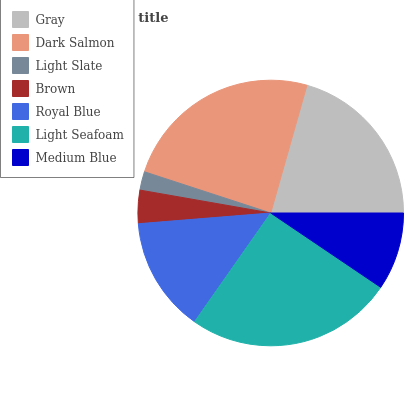Is Light Slate the minimum?
Answer yes or no. Yes. Is Light Seafoam the maximum?
Answer yes or no. Yes. Is Dark Salmon the minimum?
Answer yes or no. No. Is Dark Salmon the maximum?
Answer yes or no. No. Is Dark Salmon greater than Gray?
Answer yes or no. Yes. Is Gray less than Dark Salmon?
Answer yes or no. Yes. Is Gray greater than Dark Salmon?
Answer yes or no. No. Is Dark Salmon less than Gray?
Answer yes or no. No. Is Royal Blue the high median?
Answer yes or no. Yes. Is Royal Blue the low median?
Answer yes or no. Yes. Is Medium Blue the high median?
Answer yes or no. No. Is Light Slate the low median?
Answer yes or no. No. 